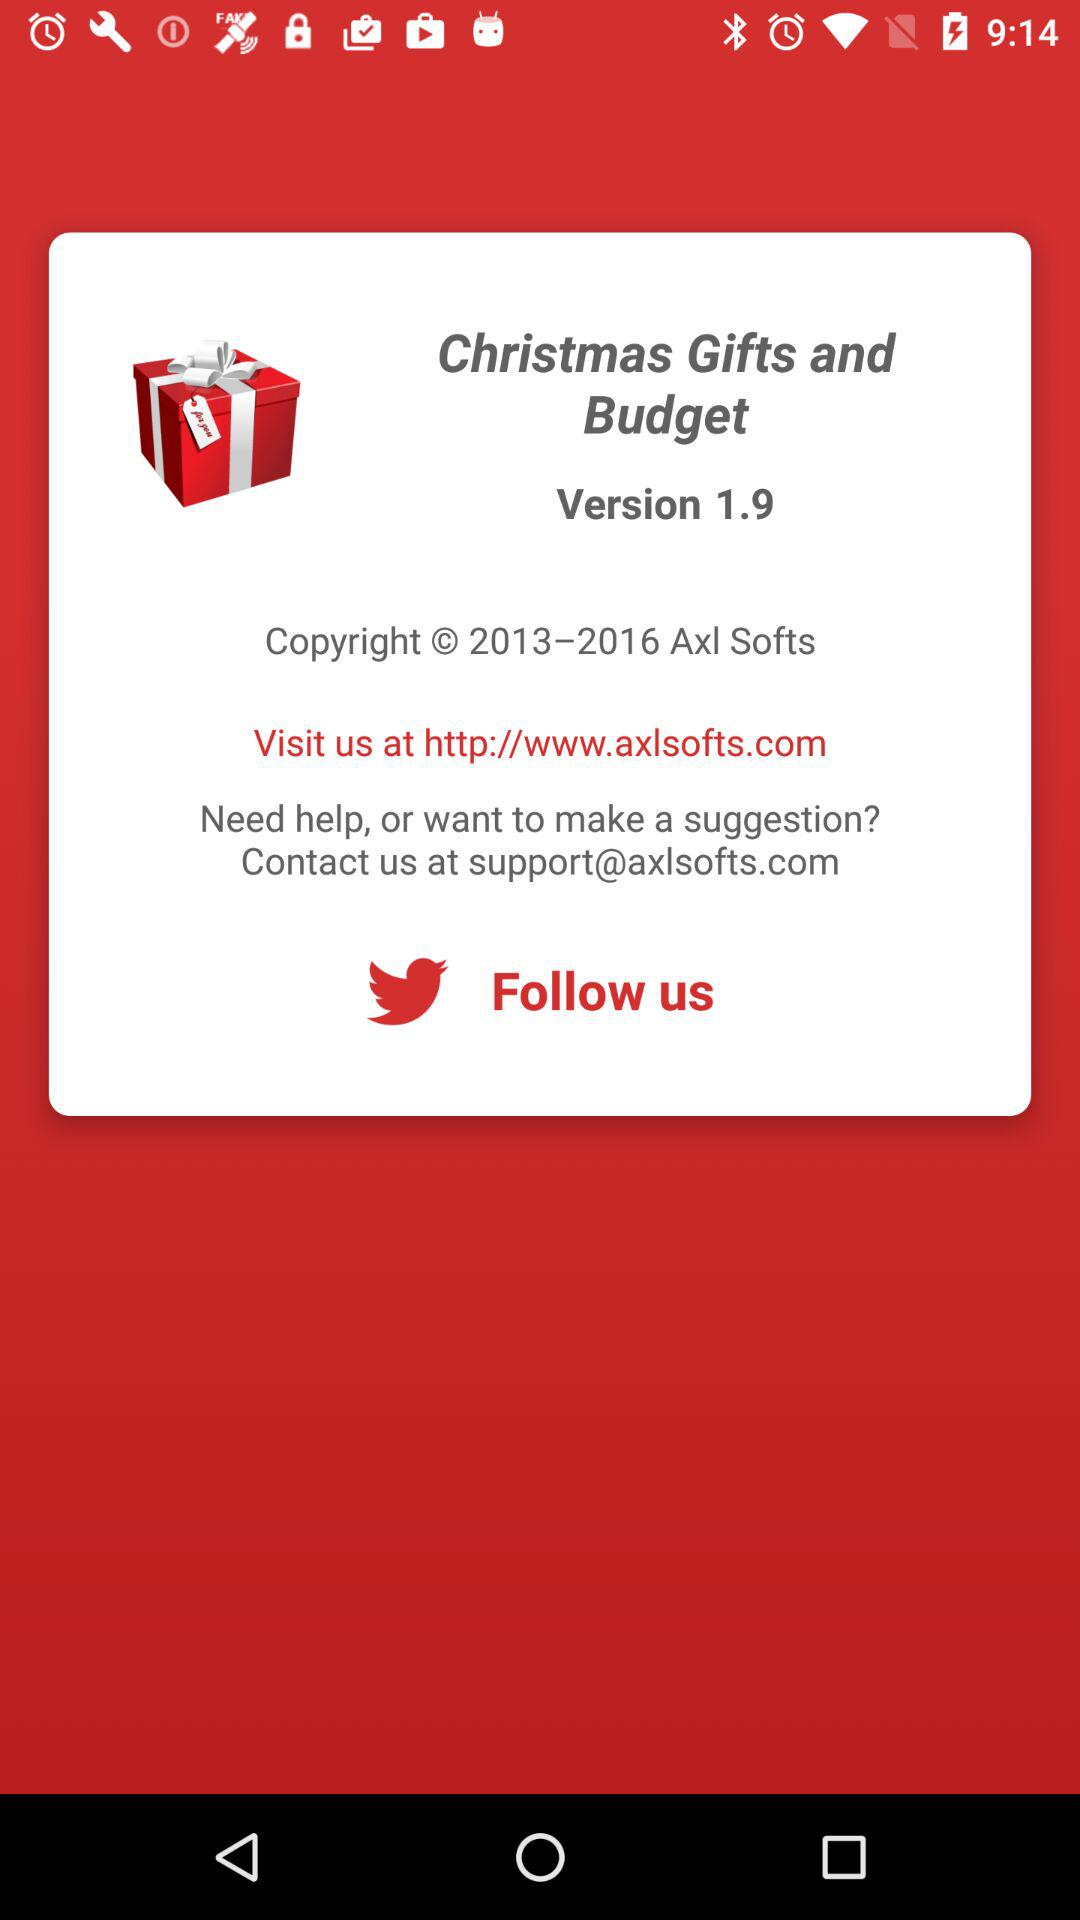Where can we follow "Axl Softs"? You can follow "Axl Softs" on "Twitter". 